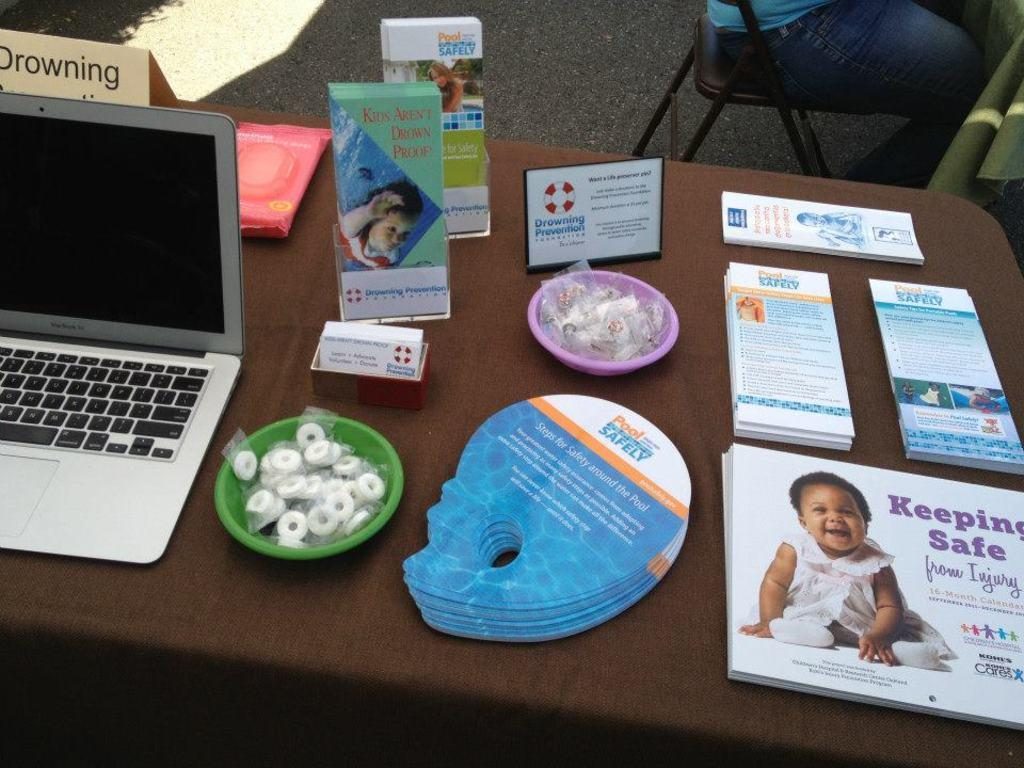<image>
Provide a brief description of the given image. A book on the table talks about keeping safe for children. 